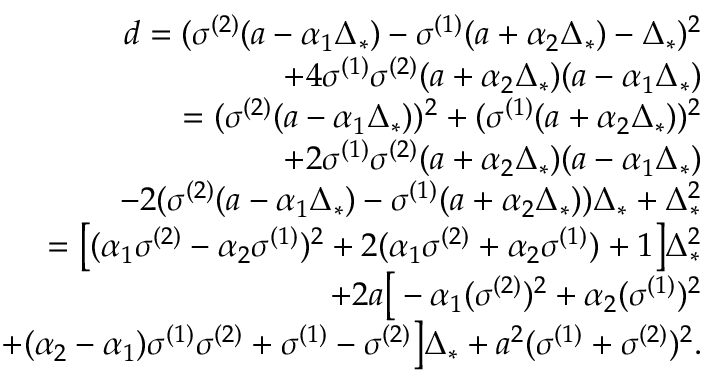<formula> <loc_0><loc_0><loc_500><loc_500>\begin{array} { r } { d = ( \sigma ^ { ( 2 ) } ( a - \alpha _ { 1 } \Delta _ { * } ) - \sigma ^ { ( 1 ) } ( a + \alpha _ { 2 } \Delta _ { * } ) - \Delta _ { * } ) ^ { 2 } } \\ { + 4 \sigma ^ { ( 1 ) } \sigma ^ { ( 2 ) } ( a + \alpha _ { 2 } \Delta _ { * } ) ( a - \alpha _ { 1 } \Delta _ { * } ) } \\ { = ( \sigma ^ { ( 2 ) } ( a - \alpha _ { 1 } \Delta _ { * } ) ) ^ { 2 } + ( \sigma ^ { ( 1 ) } ( a + \alpha _ { 2 } \Delta _ { * } ) ) ^ { 2 } } \\ { + 2 \sigma ^ { ( 1 ) } \sigma ^ { ( 2 ) } ( a + \alpha _ { 2 } \Delta _ { * } ) ( a - \alpha _ { 1 } \Delta _ { * } ) } \\ { - 2 ( \sigma ^ { ( 2 ) } ( a - \alpha _ { 1 } \Delta _ { * } ) - \sigma ^ { ( 1 ) } ( a + \alpha _ { 2 } \Delta _ { * } ) ) \Delta _ { * } + \Delta _ { * } ^ { 2 } } \\ { = \left [ ( \alpha _ { 1 } \sigma ^ { ( 2 ) } - \alpha _ { 2 } \sigma ^ { ( 1 ) } ) ^ { 2 } + 2 ( \alpha _ { 1 } \sigma ^ { ( 2 ) } + \alpha _ { 2 } \sigma ^ { ( 1 ) } ) + 1 \right ] \Delta _ { * } ^ { 2 } } \\ { + 2 a \left [ - \alpha _ { 1 } ( \sigma ^ { ( 2 ) } ) ^ { 2 } + \alpha _ { 2 } ( \sigma ^ { ( 1 ) } ) ^ { 2 } } \\ { + ( \alpha _ { 2 } - \alpha _ { 1 } ) \sigma ^ { ( 1 ) } \sigma ^ { ( 2 ) } + \sigma ^ { ( 1 ) } - \sigma ^ { ( 2 ) } \right ] \Delta _ { * } + a ^ { 2 } ( \sigma ^ { ( 1 ) } + \sigma ^ { ( 2 ) } ) ^ { 2 } . } \end{array}</formula> 